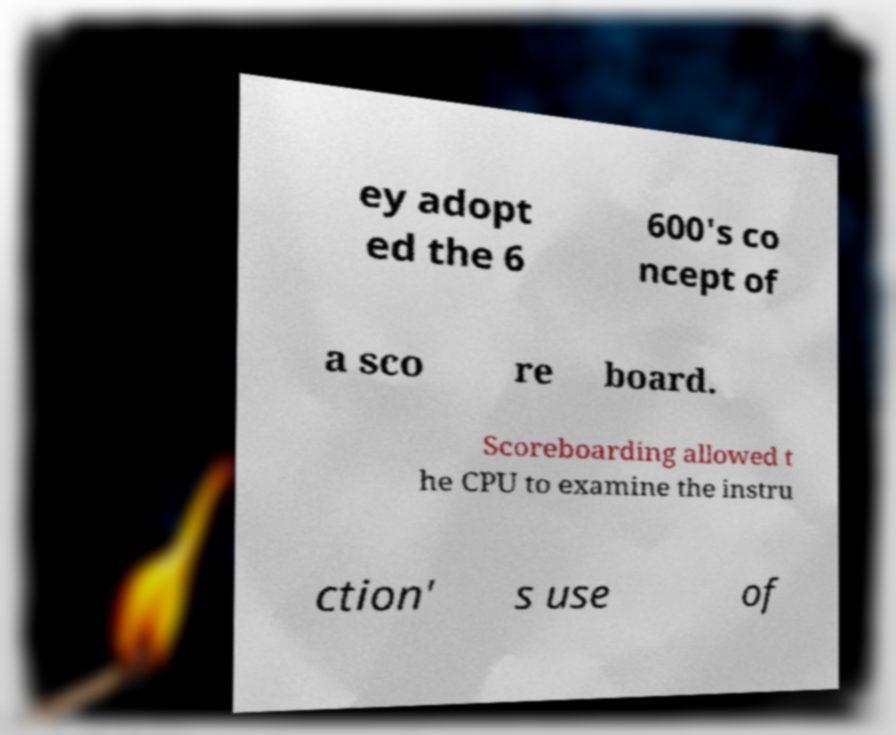Please identify and transcribe the text found in this image. ey adopt ed the 6 600's co ncept of a sco re board. Scoreboarding allowed t he CPU to examine the instru ction' s use of 